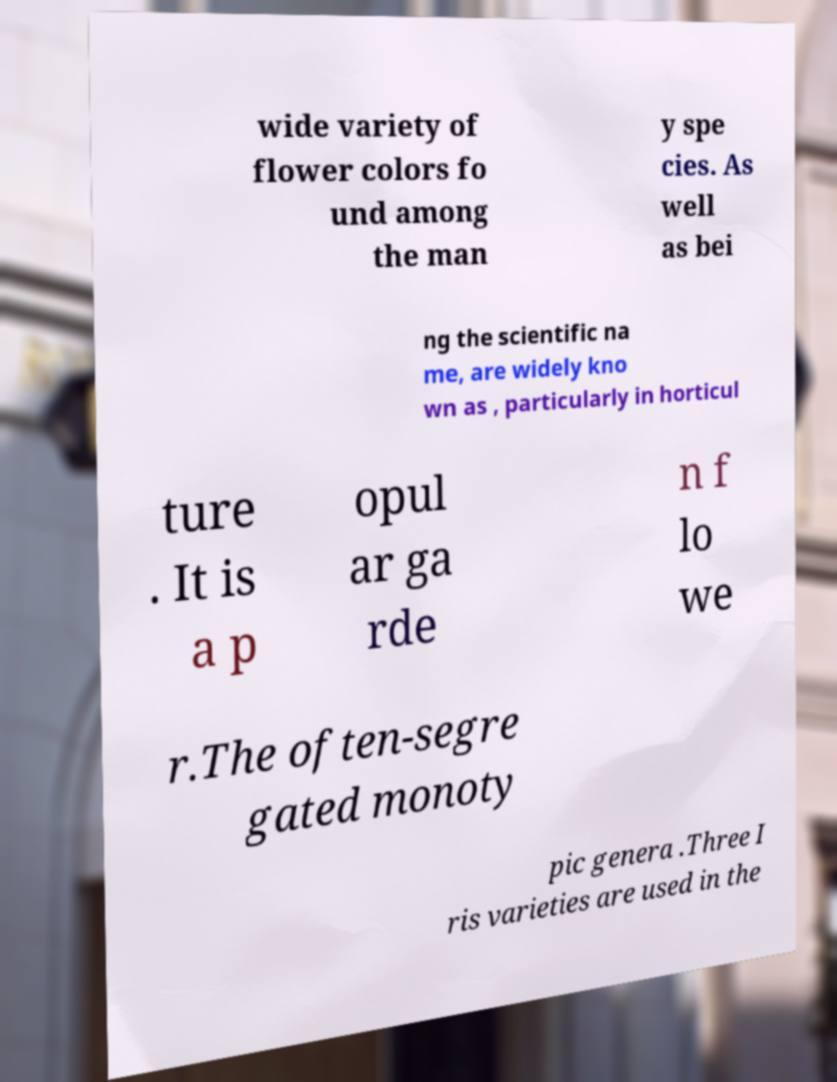Can you accurately transcribe the text from the provided image for me? wide variety of flower colors fo und among the man y spe cies. As well as bei ng the scientific na me, are widely kno wn as , particularly in horticul ture . It is a p opul ar ga rde n f lo we r.The often-segre gated monoty pic genera .Three I ris varieties are used in the 